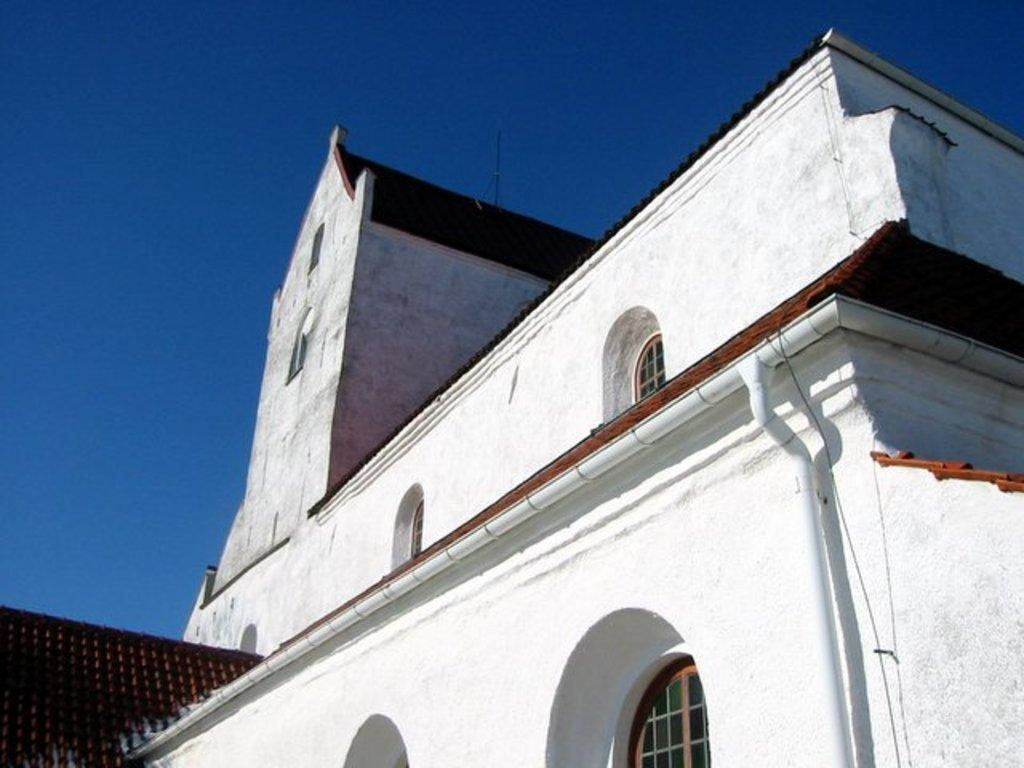What type of structure is visible in the image? There is a building in the image. What architectural feature can be seen on the building? The building has arches. What color is the sky in the image? The sky is blue in color. Can you tell me how many dogs are playing on the team in the image? There are no dogs or teams present in the image; it features a building with arches and a blue sky. 